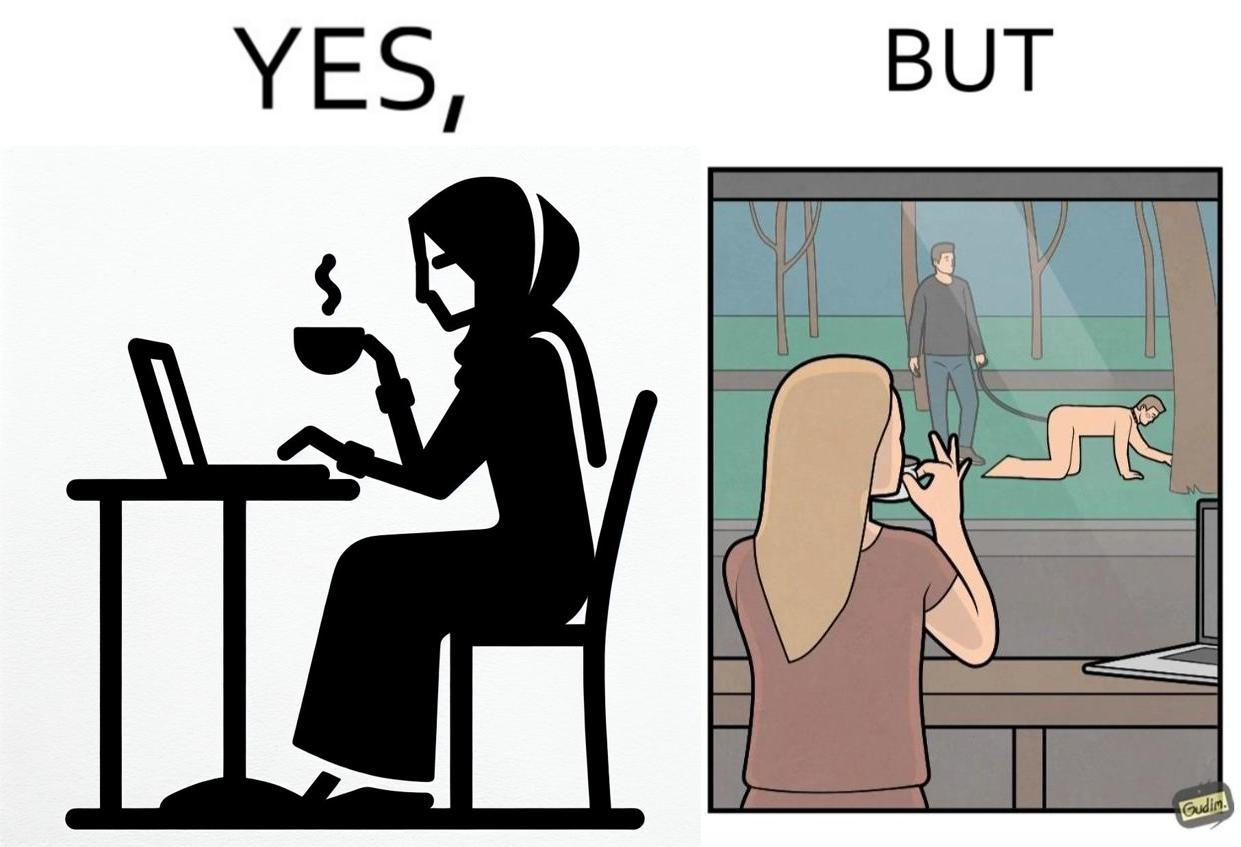Is there satirical content in this image? Yes, this image is satirical. 